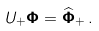Convert formula to latex. <formula><loc_0><loc_0><loc_500><loc_500>U _ { + } { \mathbf \Phi } = \widehat { \mathbf \Phi } _ { + } \, .</formula> 